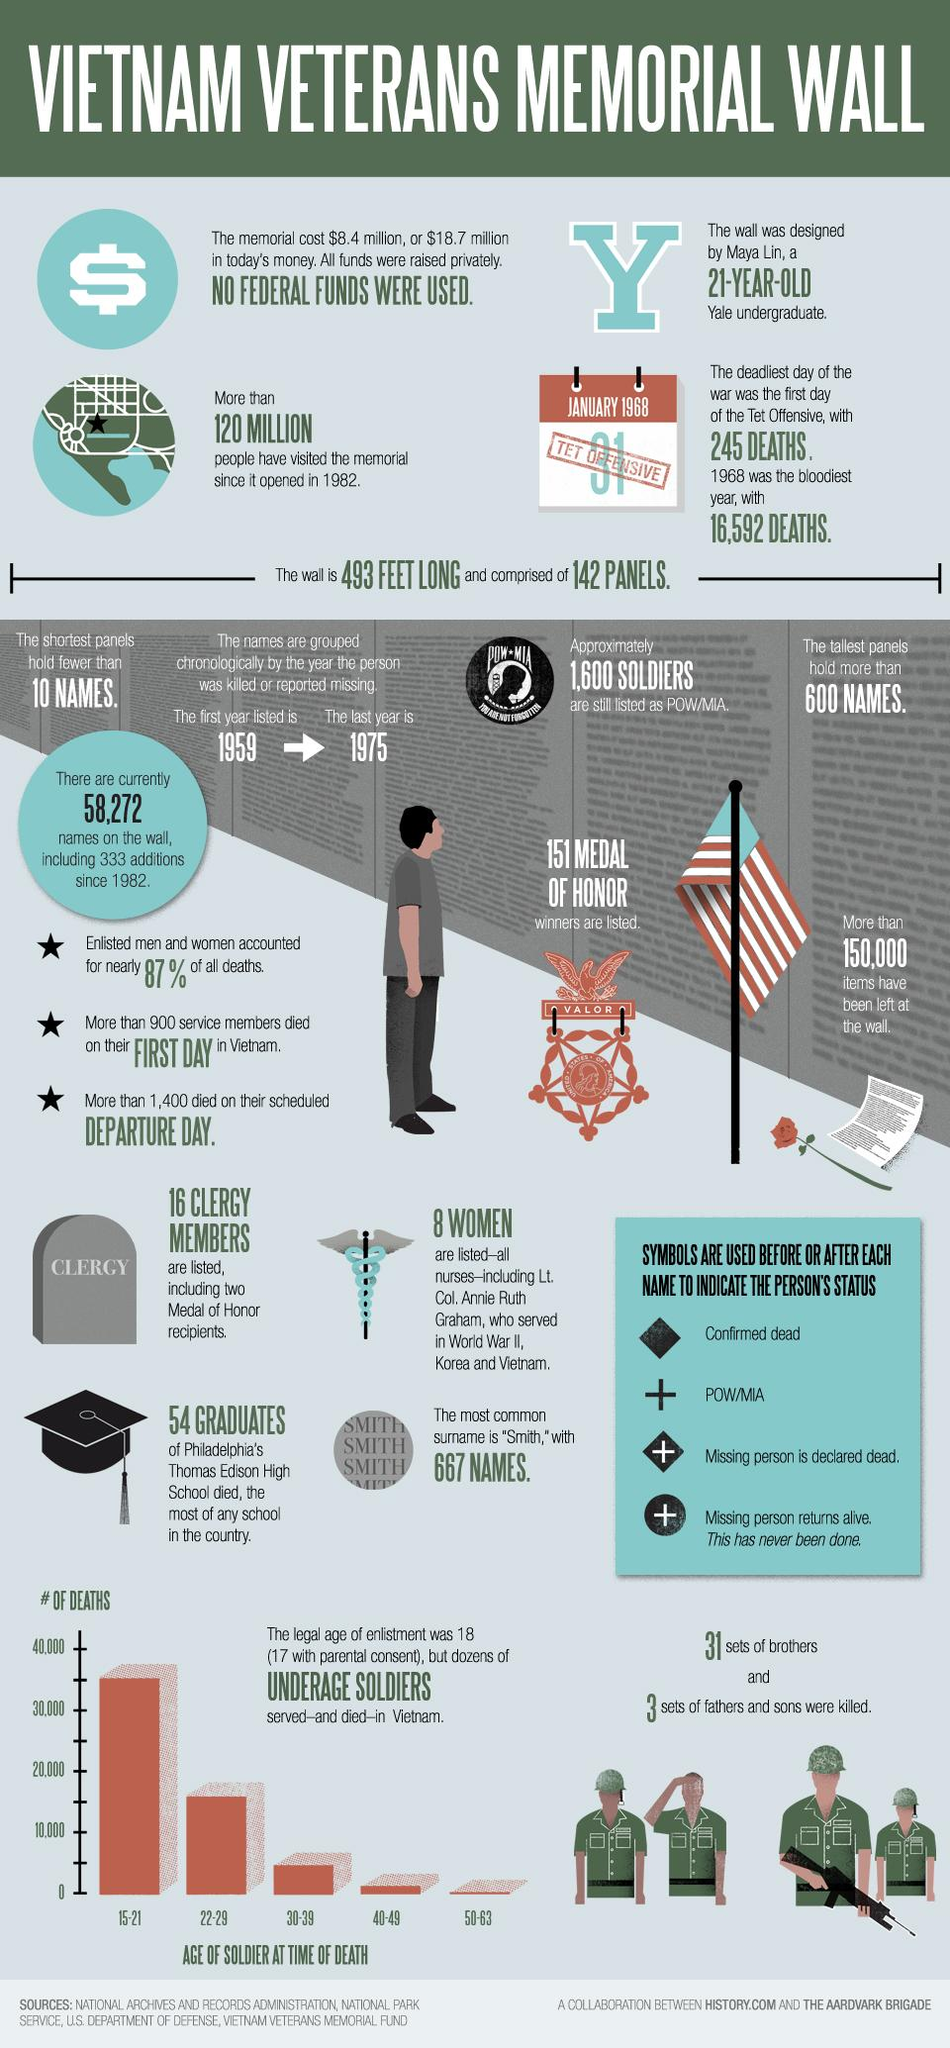Outline some significant characteristics in this image. There were approximately 35,000 soldiers who died at the age of 15-21. There were approximately 15,000 soldiers who died between the ages of 22 and 29. 